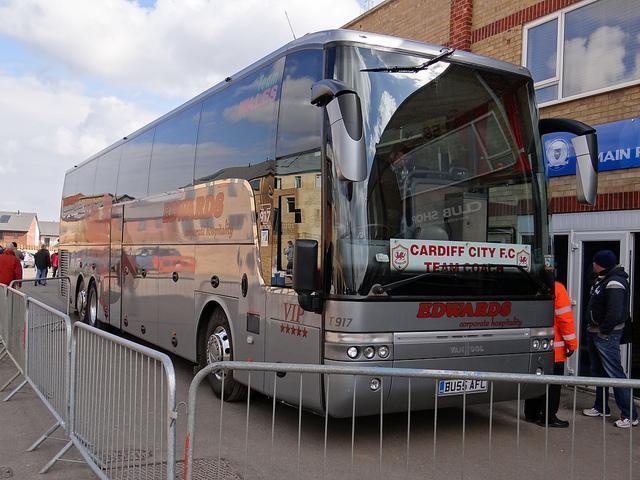Why is the man wearing an orange vest?
From the following set of four choices, select the accurate answer to respond to the question.
Options: Costume, fashion, camo, visibility. Visibility. 